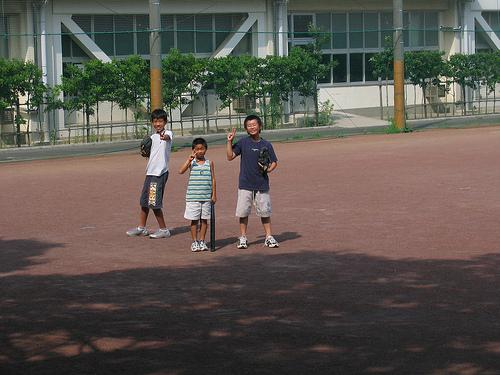Question: where is there a building?
Choices:
A. In front of the trees.
B. Behind the signs.
C. In front of the people.
D. Behind the people.
Answer with the letter. Answer: D Question: what is the person on the left holding?
Choices:
A. A baseball bat.
B. A baseball.
C. A baseball hat.
D. A baseball glove.
Answer with the letter. Answer: D Question: who is wearing a striped shirt?
Choices:
A. The person in the background.
B. The person on the left.
C. The person on the right.
D. The person in the middle.
Answer with the letter. Answer: D Question: what color shirt is the person on the left wearing?
Choices:
A. Blue.
B. Gray.
C. White.
D. Red.
Answer with the letter. Answer: C 